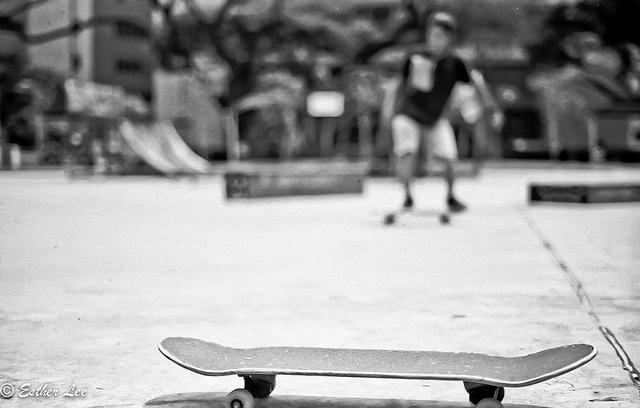What is the focus on?
Keep it brief. Skateboard. Is most of the picture in focus?
Concise answer only. No. Is the sidewalk littered with skateboards?
Be succinct. No. 